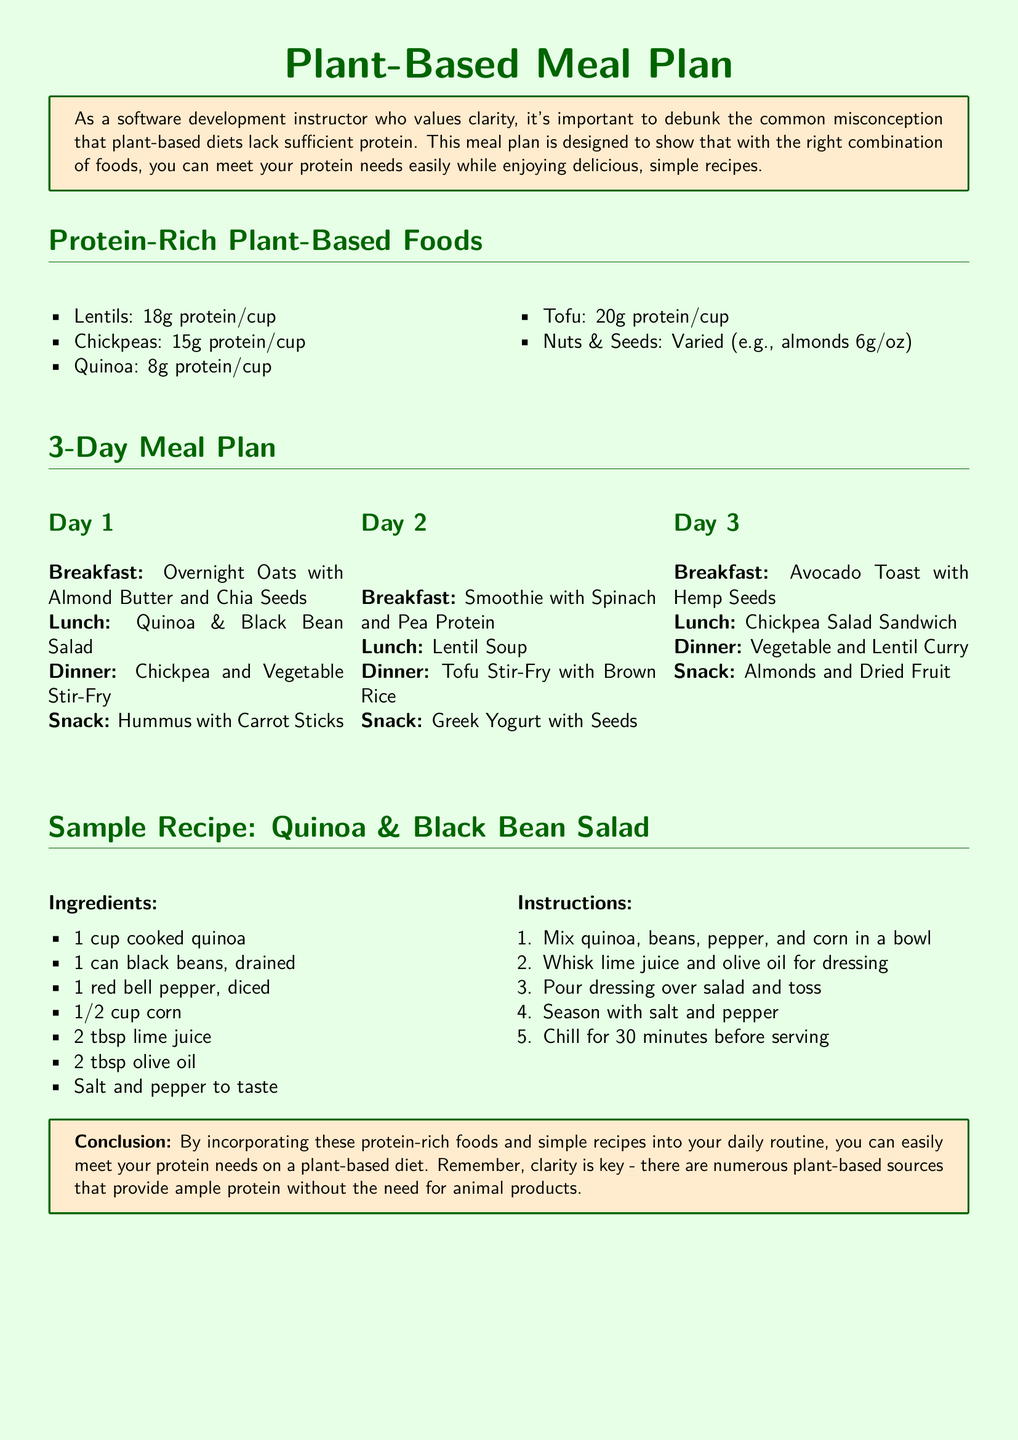What is the protein content of lentils per cup? The document states that lentils have 18 grams of protein per cup.
Answer: 18g What is a snack option listed for Day 2? The meal plan specifies "Greek Yogurt with Seeds" as a snack option for Day 2.
Answer: Greek Yogurt with Seeds How many meals are planned for Day 3? There are four meals listed for Day 3: Breakfast, Lunch, Dinner, and Snack.
Answer: 4 What is the main ingredient in the sample recipe? The sample recipe lists "1 cup cooked quinoa" as the first ingredient, indicating quinoa is the main component.
Answer: Quinoa What is the total protein content of chickpeas per cup? According to the document, chickpeas contain 15 grams of protein per cup.
Answer: 15g What type of diet does the document focus on? The document emphasizes a "plant-based diet."
Answer: Plant-based What is the function of the tcolorbox in the document? The tcolorbox is used to highlight important information and provide clarity on protein misconceptions in the meal plan.
Answer: Clarity How many days does the meal plan cover? The meal plan provides options for three different days.
Answer: 3 